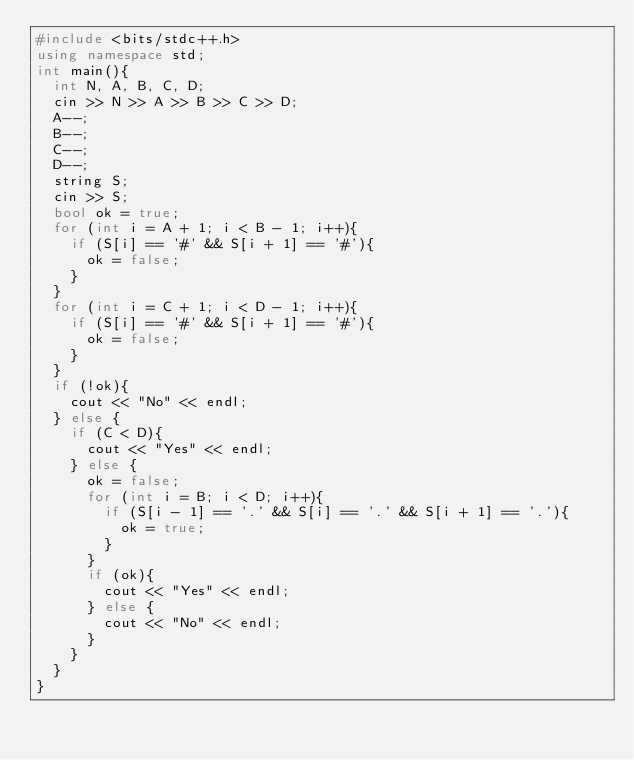Convert code to text. <code><loc_0><loc_0><loc_500><loc_500><_C++_>#include <bits/stdc++.h>
using namespace std;
int main(){
  int N, A, B, C, D;
  cin >> N >> A >> B >> C >> D;
  A--;
  B--;
  C--;
  D--;
  string S;
  cin >> S;
  bool ok = true;
  for (int i = A + 1; i < B - 1; i++){
    if (S[i] == '#' && S[i + 1] == '#'){
      ok = false;
    }
  }
  for (int i = C + 1; i < D - 1; i++){
    if (S[i] == '#' && S[i + 1] == '#'){
      ok = false;
    }
  }
  if (!ok){
    cout << "No" << endl;
  } else {
    if (C < D){
      cout << "Yes" << endl;
    } else {
      ok = false;
      for (int i = B; i < D; i++){
        if (S[i - 1] == '.' && S[i] == '.' && S[i + 1] == '.'){
          ok = true;
        }
      }
      if (ok){
        cout << "Yes" << endl;
      } else {
        cout << "No" << endl;
      }
    }
  }
}</code> 